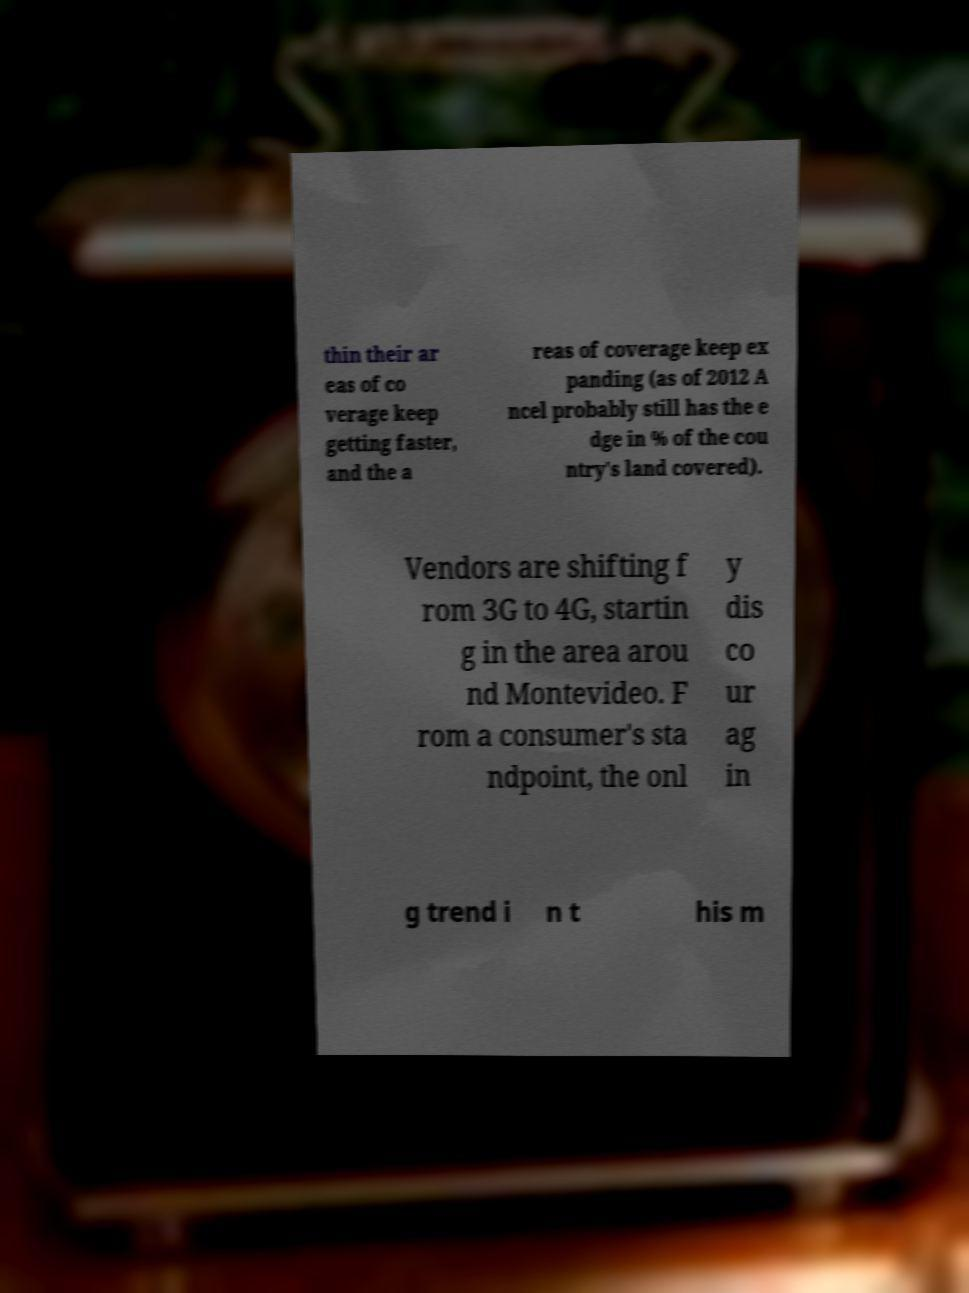Please read and relay the text visible in this image. What does it say? thin their ar eas of co verage keep getting faster, and the a reas of coverage keep ex panding (as of 2012 A ncel probably still has the e dge in % of the cou ntry's land covered). Vendors are shifting f rom 3G to 4G, startin g in the area arou nd Montevideo. F rom a consumer's sta ndpoint, the onl y dis co ur ag in g trend i n t his m 